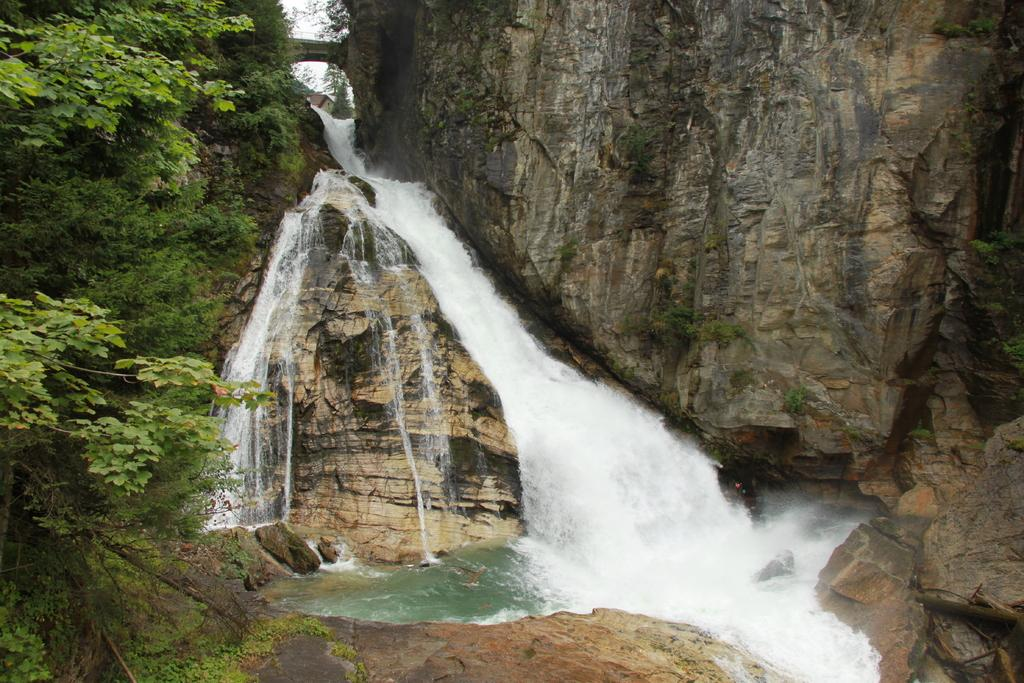What type of vegetation is on the left side of the image? There are trees on the left side of the image. What natural feature is located in the center of the image? There is a waterfall in the center of the image. What type of geological formation can be seen in the background of the image? There are rocks in the background of the image. What type of paste can be seen dripping from the icicle in the image? There is no icicle present in the image, so there is no paste to be seen. What type of board is being used to climb the waterfall in the image? There is no board or climbing activity depicted in the image; it features a waterfall and trees. 